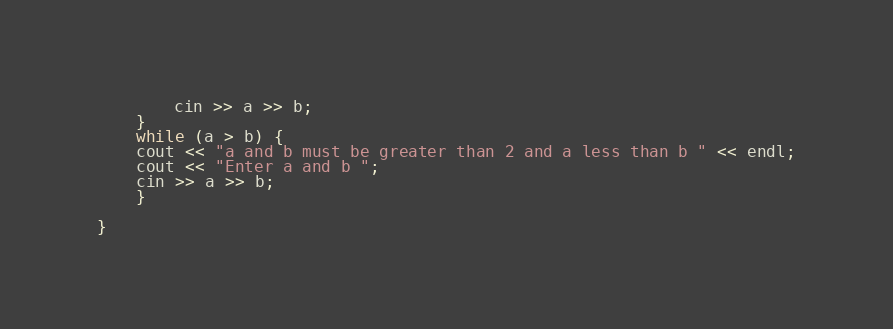<code> <loc_0><loc_0><loc_500><loc_500><_C++_>		cin >> a >> b;
	}
	while (a > b) {
	cout << "a and b must be greater than 2 and a less than b " << endl;
	cout << "Enter a and b ";
	cin >> a >> b;
	}
	
}</code> 